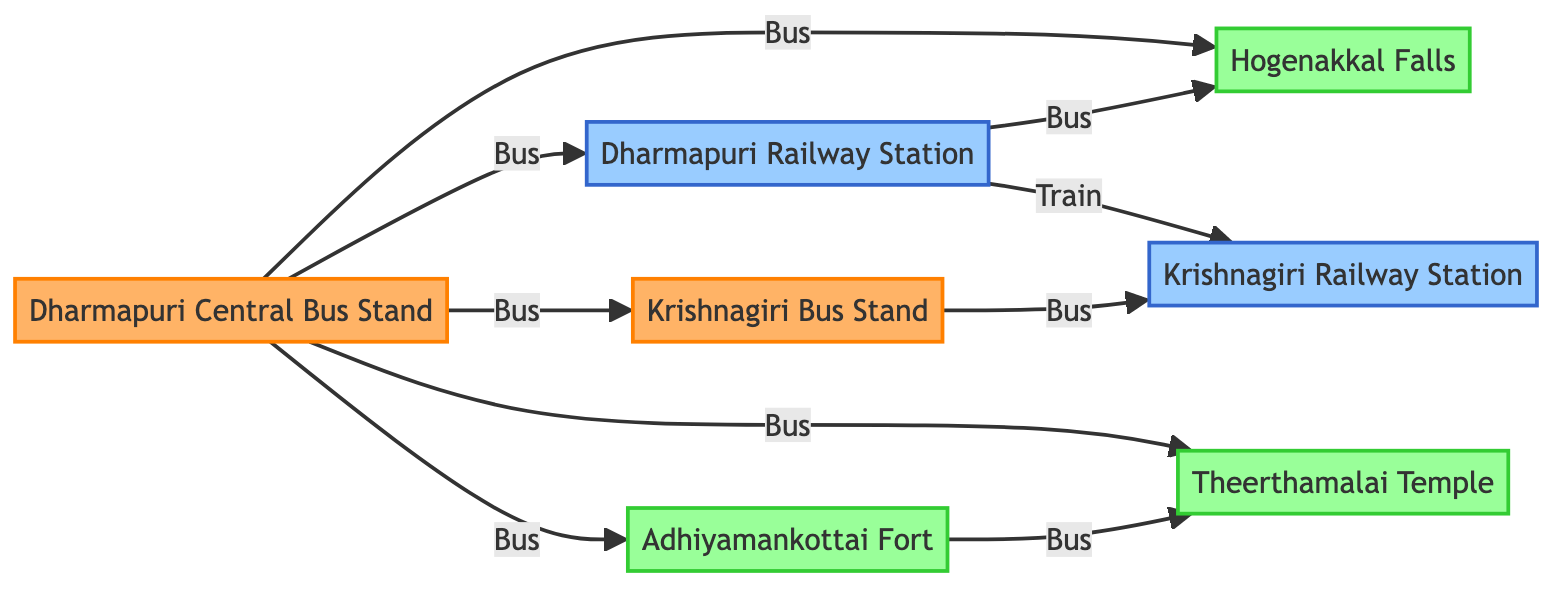What is the total number of nodes in the diagram? The nodes represent different locations, and by counting them, we find there are 7 distinct locations: Dharmapuri Central Bus Stand, Dharmapuri Railway Station, Hogenakkal Falls, Adhiyamankottai Fort, Theerthamalai Temple, Krishnagiri Bus Stand, and Krishnagiri Railway Station.
Answer: 7 Which bus stop connects directly to the train station? Reviewing the links, the Dharmapuri Central Bus Stand has a direct bus link to the Dharmapuri Railway Station. Other bus stops do not connect directly to the train station.
Answer: Dharmapuri Central Bus Stand How many tourist spots are connected to the Dharmapuri Central Bus Stand? By examining the links from the Dharmapuri Central Bus Stand, we see it connects to three tourist spots: Hogenakkal Falls, Adhiyamankottai Fort, and Theerthamalai Temple.
Answer: 3 What mode of transport is used between Krishnagiri Bus Stand and Krishnagiri Railway Station? The link between Krishnagiri Bus Stand and Krishnagiri Railway Station specifically indicates that it is a bus transport connection.
Answer: Bus Which tourist spot is directly connected to Adhiyamankottai Fort? The link shows that the Adhiyamankottai Fort is directly connected to the Theerthamalai Temple by a bus transport mode.
Answer: Theerthamalai Temple From which bus stop can one reach both Hogenakkal Falls and Adhiyamankottai Fort? The Dharmapuri Central Bus Stand provides direct bus links to both Hogenakkal Falls and Adhiyamankottai Fort, allowing access to both from the same location.
Answer: Dharmapuri Central Bus Stand How many connections lead out from Dharmapuri Central Bus Stand? Counting the outgoing links from the Dharmapuri Central Bus Stand shows there are five connections leading to different destinations: Dharmapuri Railway Station, Hogenakkal Falls, Adhiyamankottai Fort, Theerthamalai Temple, and Krishnagiri Bus Stand.
Answer: 5 What type of node is the Dharmapuri Railway Station? The node type representing the Dharmapuri Railway Station is categorized as a train station, indicated in the diagram’s classification.
Answer: Train Station Which location is the furthest destination from Dharmapuri Central Bus Stand by direct transport? Tracing the links, the furthest destination—considering the direct transport routes—is the Krishnagiri Railway Station, accessed via transfers at Krishnagiri Bus Stand and Dharmapuri Railway Station.
Answer: Krishnagiri Railway Station 